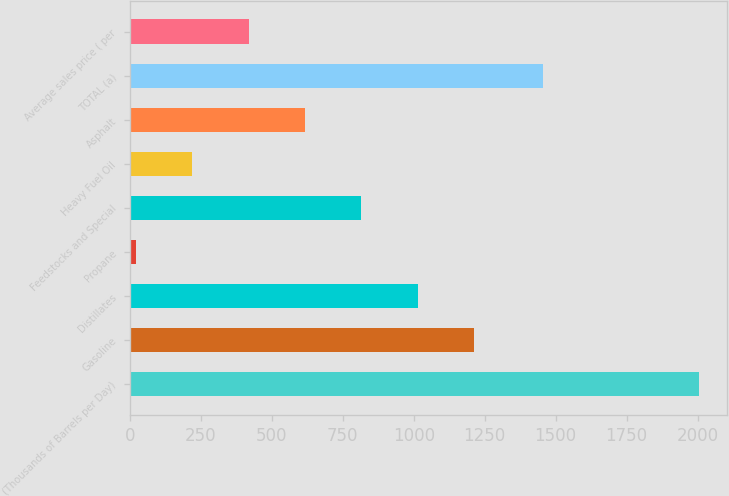Convert chart to OTSL. <chart><loc_0><loc_0><loc_500><loc_500><bar_chart><fcel>(Thousands of Barrels per Day)<fcel>Gasoline<fcel>Distillates<fcel>Propane<fcel>Feedstocks and Special<fcel>Heavy Fuel Oil<fcel>Asphalt<fcel>TOTAL (a)<fcel>Average sales price ( per<nl><fcel>2005<fcel>1211.8<fcel>1013.5<fcel>22<fcel>815.2<fcel>220.3<fcel>616.9<fcel>1455<fcel>418.6<nl></chart> 